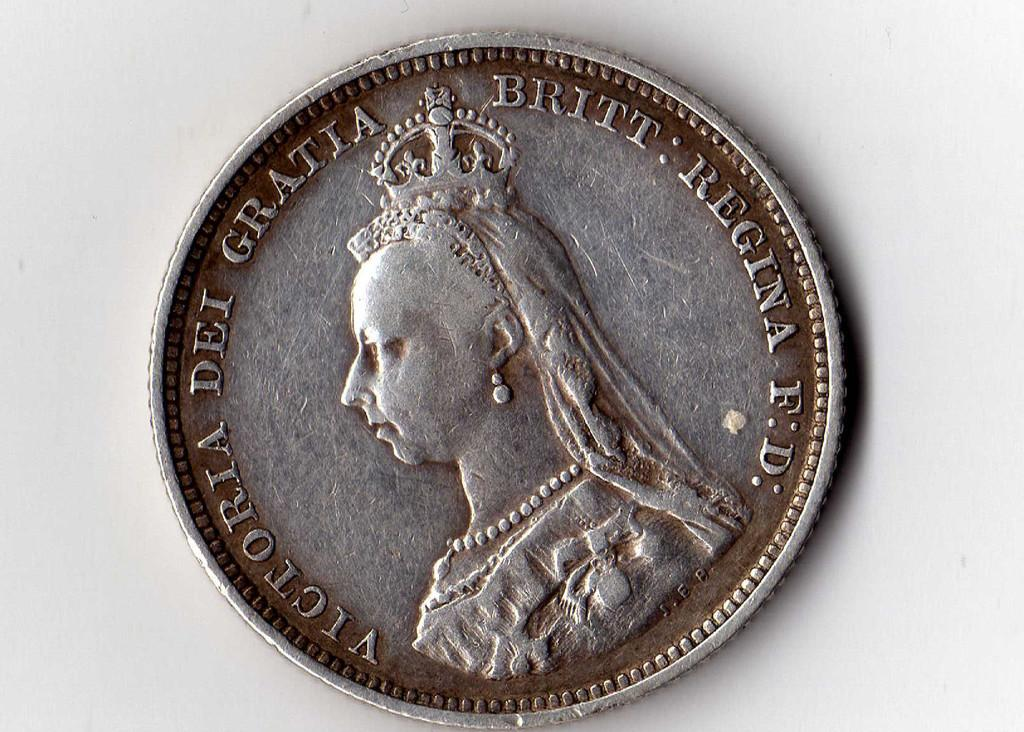<image>
Present a compact description of the photo's key features. A Victoria Dei Gratia coin has Queen Victoria on it. 